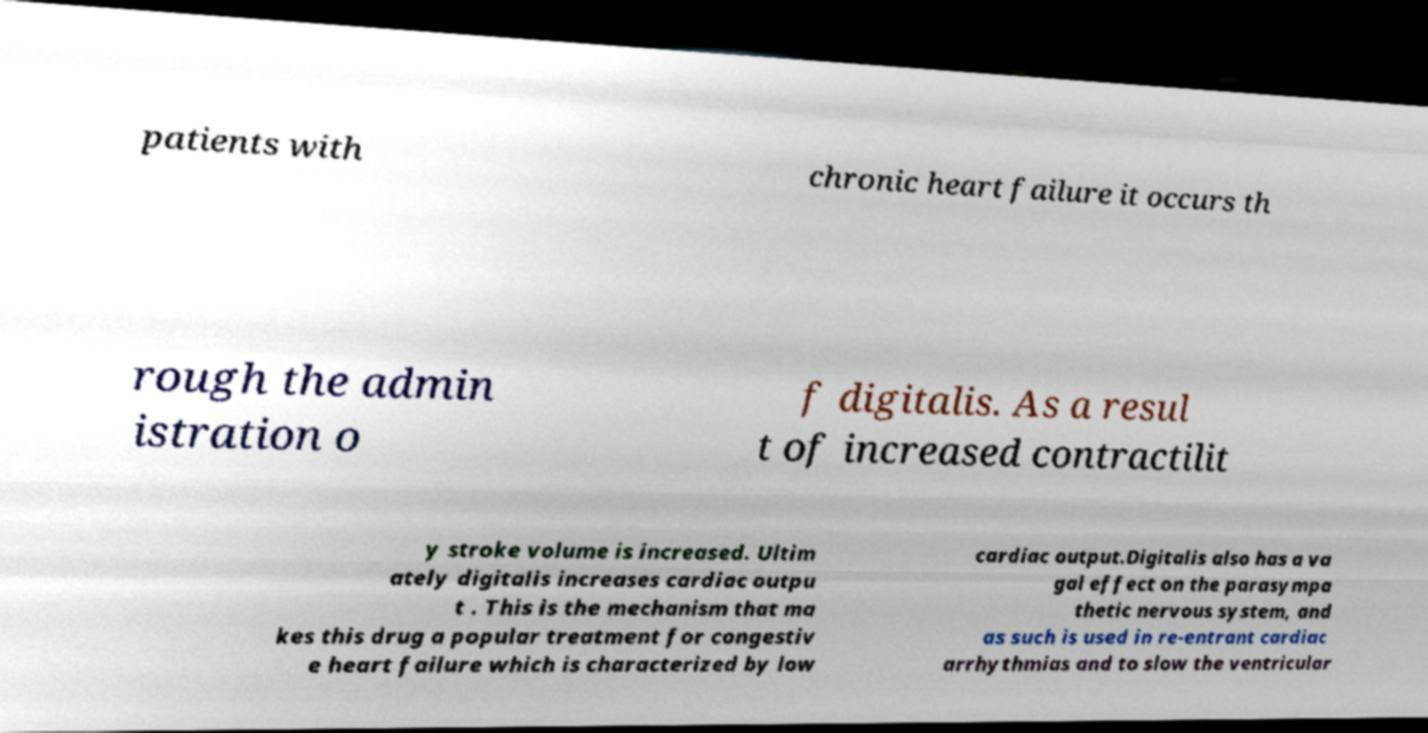Could you extract and type out the text from this image? patients with chronic heart failure it occurs th rough the admin istration o f digitalis. As a resul t of increased contractilit y stroke volume is increased. Ultim ately digitalis increases cardiac outpu t . This is the mechanism that ma kes this drug a popular treatment for congestiv e heart failure which is characterized by low cardiac output.Digitalis also has a va gal effect on the parasympa thetic nervous system, and as such is used in re-entrant cardiac arrhythmias and to slow the ventricular 